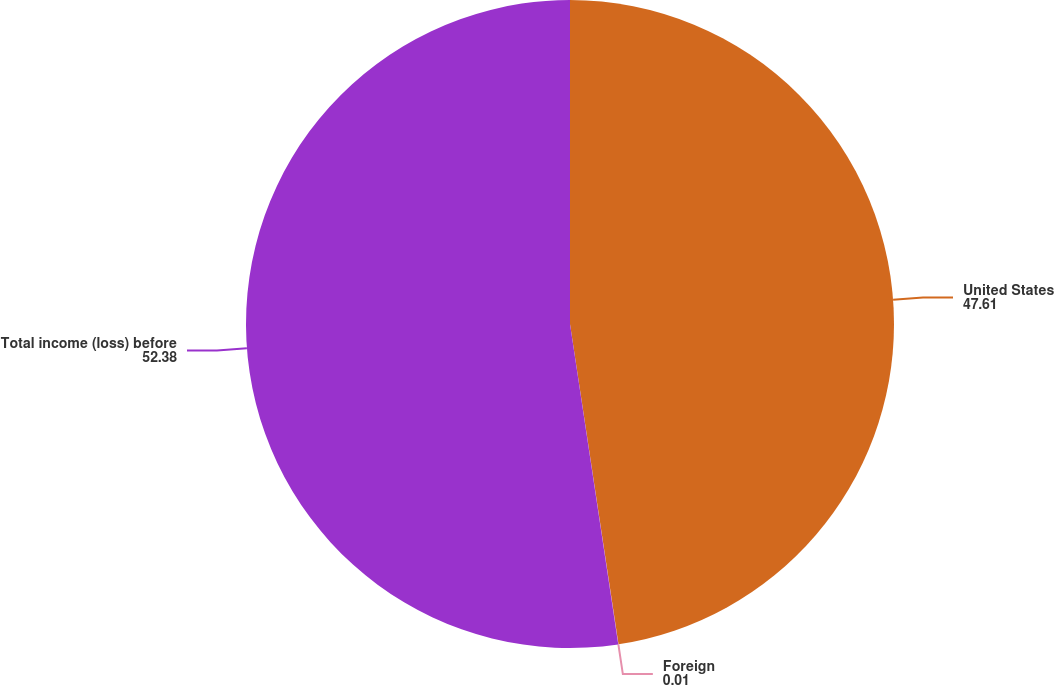Convert chart to OTSL. <chart><loc_0><loc_0><loc_500><loc_500><pie_chart><fcel>United States<fcel>Foreign<fcel>Total income (loss) before<nl><fcel>47.61%<fcel>0.01%<fcel>52.38%<nl></chart> 